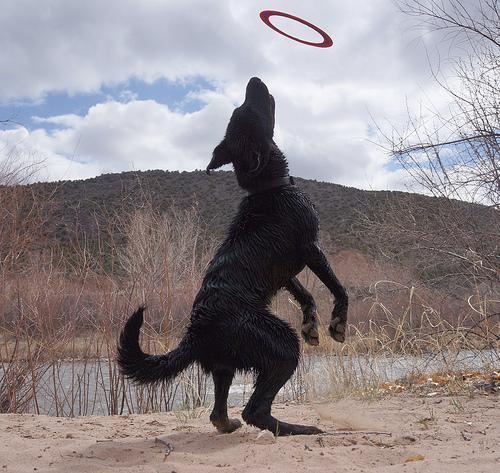How many legs is the dog standing on?
Give a very brief answer. 2. 